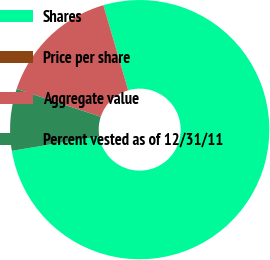<chart> <loc_0><loc_0><loc_500><loc_500><pie_chart><fcel>Shares<fcel>Price per share<fcel>Aggregate value<fcel>Percent vested as of 12/31/11<nl><fcel>76.9%<fcel>0.01%<fcel>15.39%<fcel>7.7%<nl></chart> 